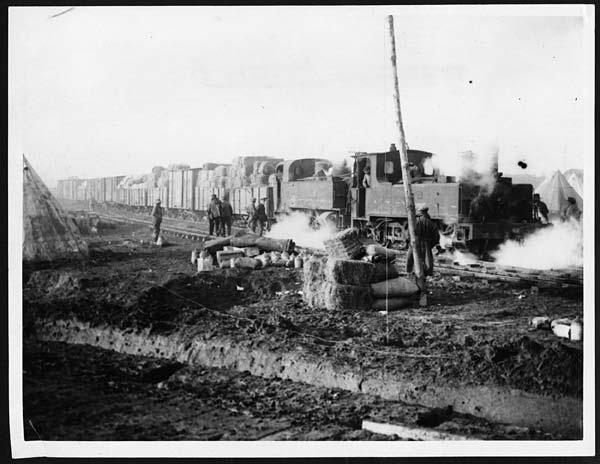Is this photo old?
Answer briefly. Yes. What color is dominant?
Be succinct. Black. What are the people doing?
Concise answer only. Working. Where is the telephone pole in relation to the train?
Be succinct. Left. What is loaded on the train?
Keep it brief. Hay. Is this in color?
Quick response, please. No. Are there any people in this photo?
Quick response, please. Yes. Where are the cars going?
Short answer required. Right. Is this a park?
Give a very brief answer. No. What is the fence made out of?
Keep it brief. Wire. Is the bridge broke?
Concise answer only. No. Was this photograph taken in the 19th century?
Concise answer only. Yes. What type of cargo is most likely on this train?
Be succinct. Hay. 